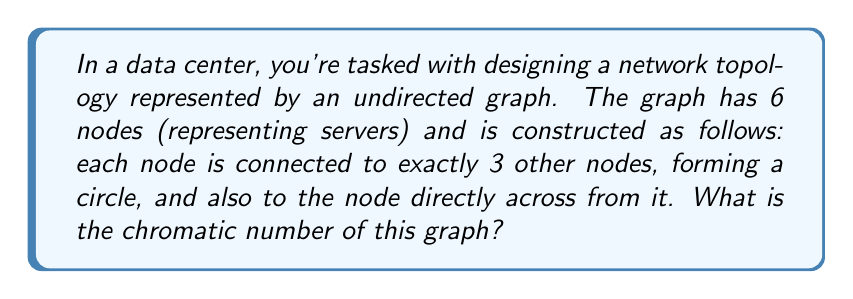Can you solve this math problem? To solve this problem, let's approach it step-by-step:

1) First, let's visualize the graph:

[asy]
unitsize(2cm);
pair[] A = new pair[6];
for (int i=0; i<6; ++i) {
  A[i] = dir(60*i);
}
for (int i=0; i<6; ++i) {
  draw(A[i]--A[(i+1)%6]);
  draw(A[i]--A[(i+3)%6], dashed);
}
for (int i=0; i<6; ++i) {
  dot(A[i]);
}
[/asy]

2) The chromatic number of a graph is the minimum number of colors needed to color the vertices such that no two adjacent vertices share the same color.

3) In this graph, each vertex is connected to 4 other vertices (3 in the circle and 1 across).

4) Let's try to color the graph:
   - Start with one vertex and color it (say, red).
   - Its three adjacent vertices in the circle and the one across must all be different colors (say, blue, green, yellow, and purple).
   - The last remaining vertex must be connected to three of these colored vertices, so it must be the same color as the first vertex we colored (red).

5) This coloring uses 5 colors, and we can't use fewer because:
   - Each vertex is connected to 4 others, so at least 5 colors are needed.
   - We've shown a valid 5-coloring exists.

6) Therefore, the chromatic number of this graph is 5.

This topology is actually a specific graph known as the Paley graph of order 5, which is also the same as the 5-cell graph. It's a well-known graph in topology and graph theory.
Answer: The chromatic number of the given graph is 5. 